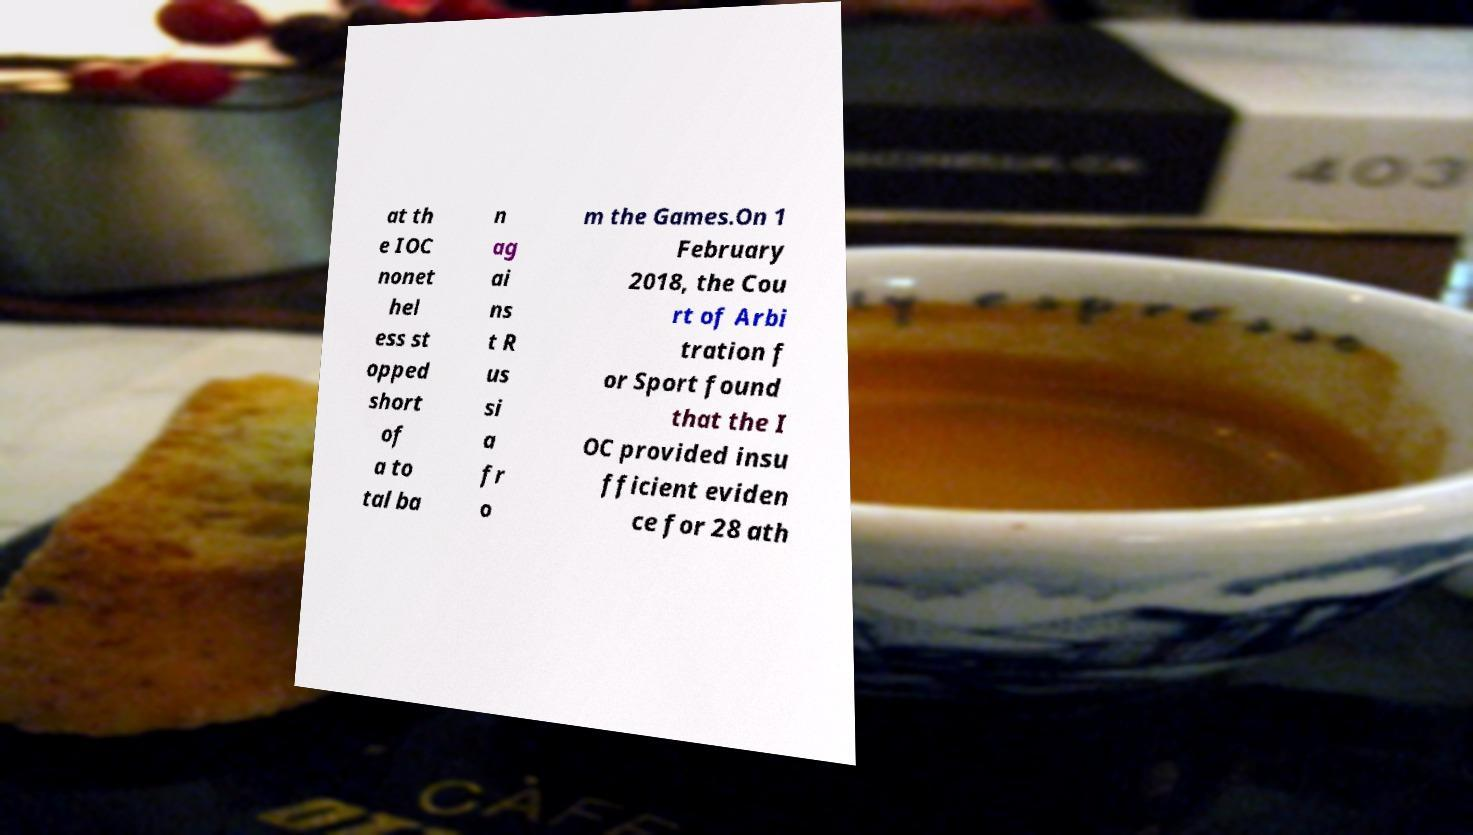Please identify and transcribe the text found in this image. at th e IOC nonet hel ess st opped short of a to tal ba n ag ai ns t R us si a fr o m the Games.On 1 February 2018, the Cou rt of Arbi tration f or Sport found that the I OC provided insu fficient eviden ce for 28 ath 